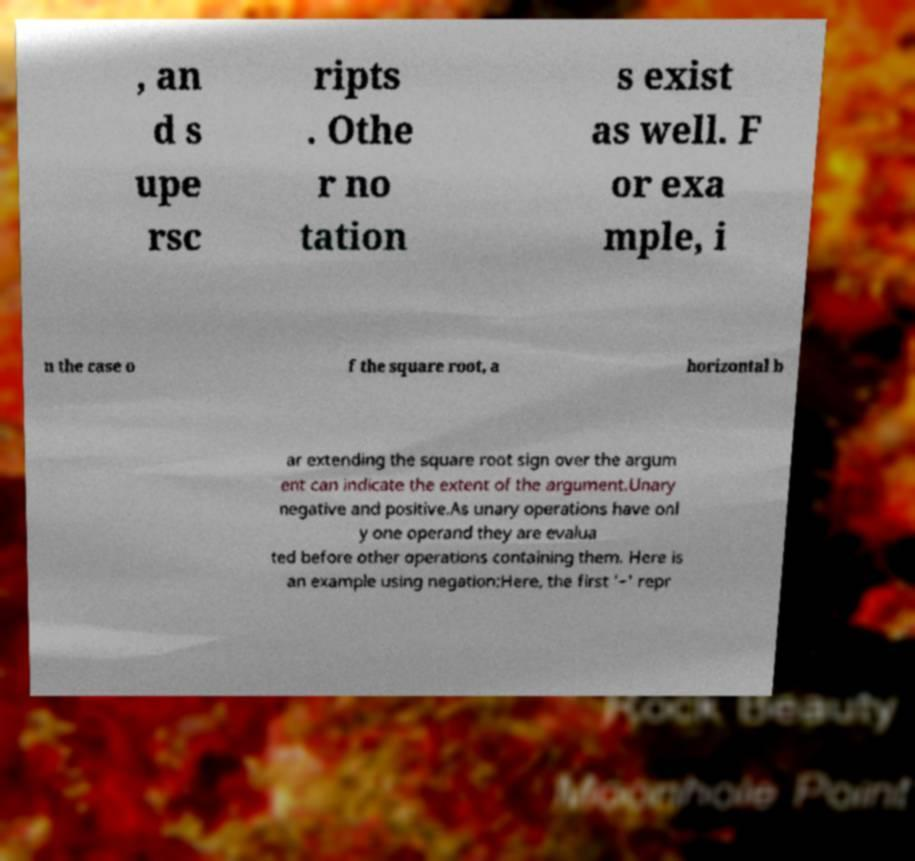Could you assist in decoding the text presented in this image and type it out clearly? , an d s upe rsc ripts . Othe r no tation s exist as well. F or exa mple, i n the case o f the square root, a horizontal b ar extending the square root sign over the argum ent can indicate the extent of the argument.Unary negative and positive.As unary operations have onl y one operand they are evalua ted before other operations containing them. Here is an example using negation:Here, the first '−' repr 